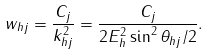<formula> <loc_0><loc_0><loc_500><loc_500>w _ { h j } = \frac { C _ { j } } { k ^ { 2 } _ { h j } } = \frac { C _ { j } } { 2 E ^ { 2 } _ { h } \sin ^ { 2 } \theta _ { h j } / 2 } .</formula> 